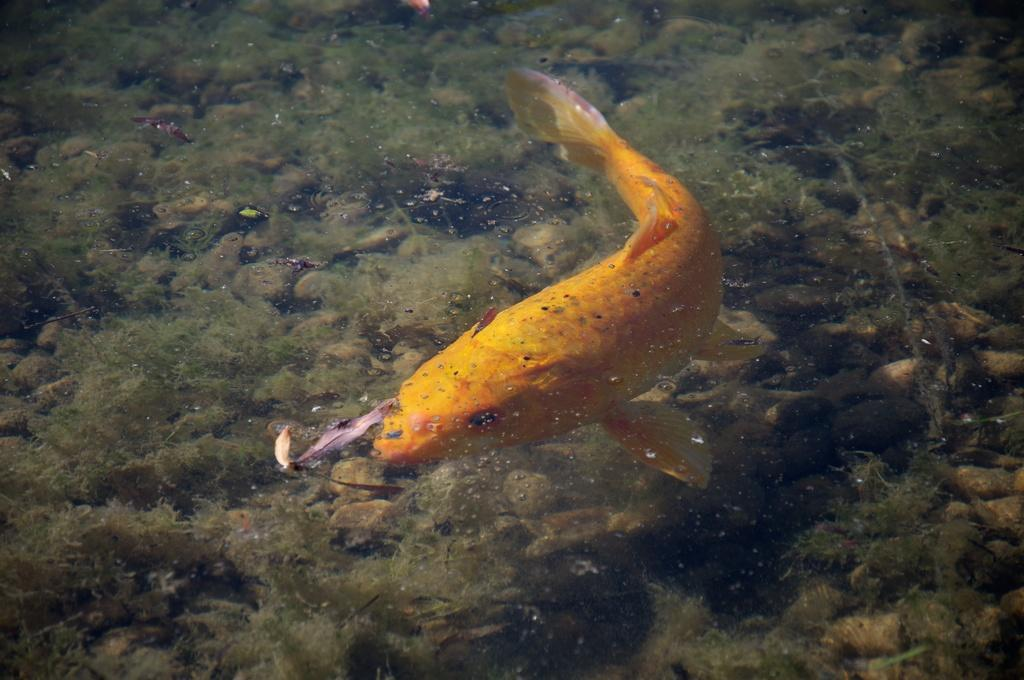What type of animal is in the image? There is a fish in the image. What color is the fish? The fish is yellow in color. Where is the fish located? The fish is in the water. What can be seen in the background of the image? There are small plants in the background of the image. What color are the plants? The plants are green in color. How many sisters does the fish have in the image? There are no sisters mentioned or depicted in the image, as it features a fish in the water with small plants in the background. 